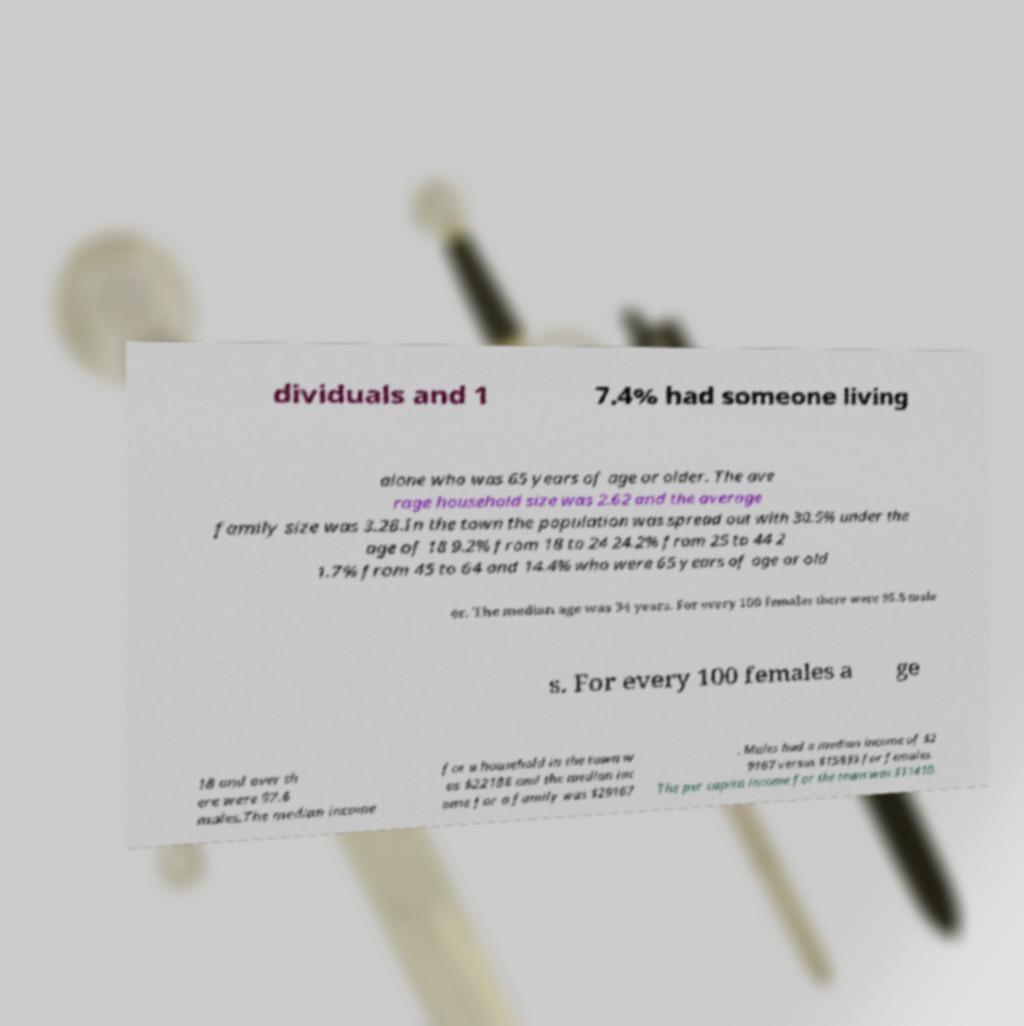For documentation purposes, I need the text within this image transcribed. Could you provide that? dividuals and 1 7.4% had someone living alone who was 65 years of age or older. The ave rage household size was 2.62 and the average family size was 3.28.In the town the population was spread out with 30.5% under the age of 18 9.2% from 18 to 24 24.2% from 25 to 44 2 1.7% from 45 to 64 and 14.4% who were 65 years of age or old er. The median age was 34 years. For every 100 females there were 95.8 male s. For every 100 females a ge 18 and over th ere were 97.6 males.The median income for a household in the town w as $22188 and the median inc ome for a family was $29167 . Males had a median income of $2 9167 versus $15833 for females. The per capita income for the town was $11410. 